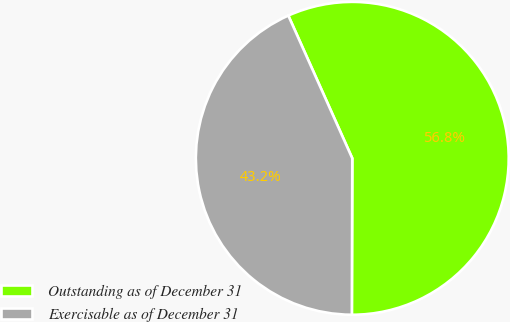Convert chart. <chart><loc_0><loc_0><loc_500><loc_500><pie_chart><fcel>Outstanding as of December 31<fcel>Exercisable as of December 31<nl><fcel>56.75%<fcel>43.25%<nl></chart> 